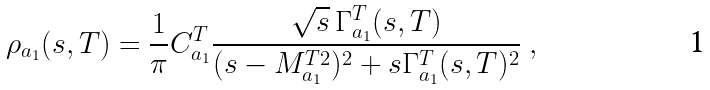<formula> <loc_0><loc_0><loc_500><loc_500>\rho _ { a _ { 1 } } ( s , T ) = \frac { 1 } { \pi } { C } ^ { T } _ { a _ { 1 } } \frac { \sqrt { s } \, \Gamma _ { a _ { 1 } } ^ { T } ( s , T ) } { ( s - M _ { a _ { 1 } } ^ { T 2 } ) ^ { 2 } + s \Gamma _ { a _ { 1 } } ^ { T } ( s , T ) ^ { 2 } } \ ,</formula> 